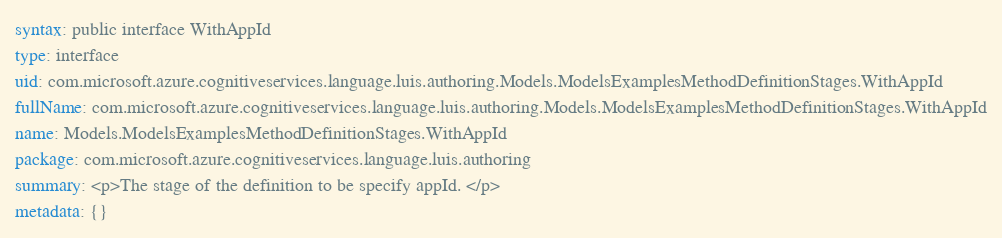<code> <loc_0><loc_0><loc_500><loc_500><_YAML_>syntax: public interface WithAppId
type: interface
uid: com.microsoft.azure.cognitiveservices.language.luis.authoring.Models.ModelsExamplesMethodDefinitionStages.WithAppId
fullName: com.microsoft.azure.cognitiveservices.language.luis.authoring.Models.ModelsExamplesMethodDefinitionStages.WithAppId
name: Models.ModelsExamplesMethodDefinitionStages.WithAppId
package: com.microsoft.azure.cognitiveservices.language.luis.authoring
summary: <p>The stage of the definition to be specify appId. </p>
metadata: {}
</code> 